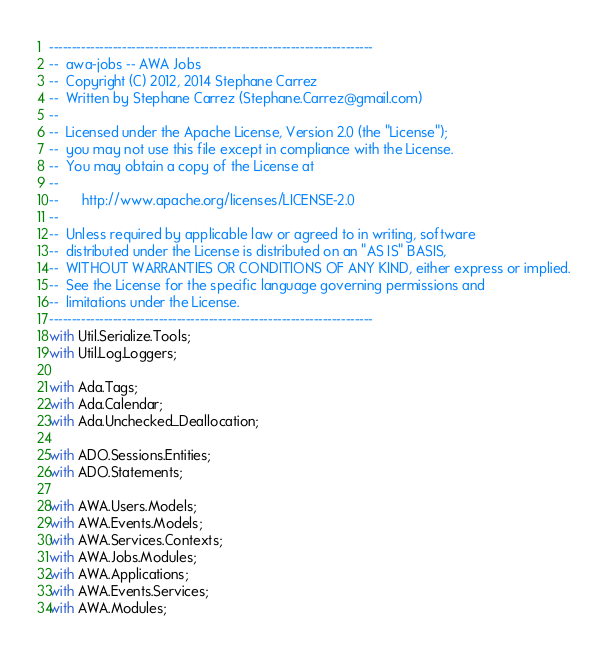Convert code to text. <code><loc_0><loc_0><loc_500><loc_500><_Ada_>-----------------------------------------------------------------------
--  awa-jobs -- AWA Jobs
--  Copyright (C) 2012, 2014 Stephane Carrez
--  Written by Stephane Carrez (Stephane.Carrez@gmail.com)
--
--  Licensed under the Apache License, Version 2.0 (the "License");
--  you may not use this file except in compliance with the License.
--  You may obtain a copy of the License at
--
--      http://www.apache.org/licenses/LICENSE-2.0
--
--  Unless required by applicable law or agreed to in writing, software
--  distributed under the License is distributed on an "AS IS" BASIS,
--  WITHOUT WARRANTIES OR CONDITIONS OF ANY KIND, either express or implied.
--  See the License for the specific language governing permissions and
--  limitations under the License.
-----------------------------------------------------------------------
with Util.Serialize.Tools;
with Util.Log.Loggers;

with Ada.Tags;
with Ada.Calendar;
with Ada.Unchecked_Deallocation;

with ADO.Sessions.Entities;
with ADO.Statements;

with AWA.Users.Models;
with AWA.Events.Models;
with AWA.Services.Contexts;
with AWA.Jobs.Modules;
with AWA.Applications;
with AWA.Events.Services;
with AWA.Modules;</code> 